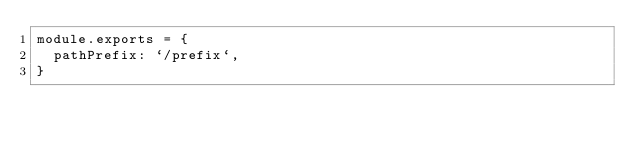<code> <loc_0><loc_0><loc_500><loc_500><_JavaScript_>module.exports = {
  pathPrefix: `/prefix`,
}
</code> 